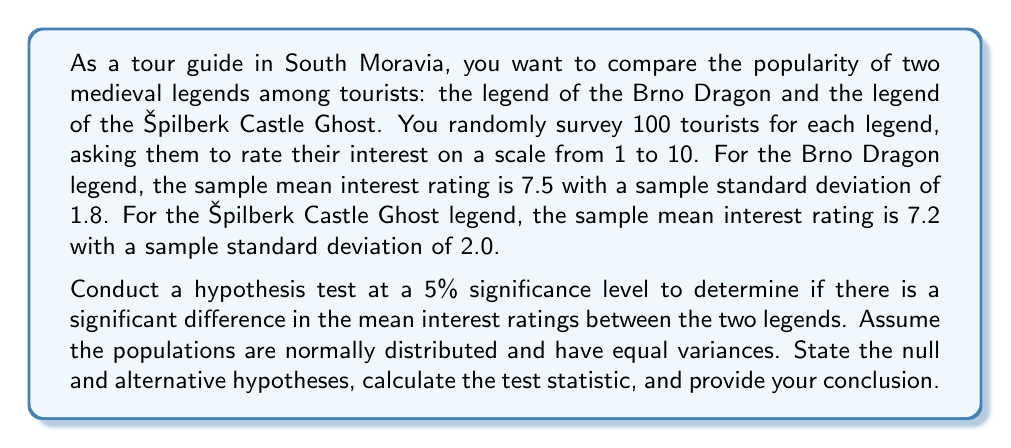Can you answer this question? Let's approach this step-by-step:

1) First, let's state our hypotheses:

   $H_0: \mu_1 = \mu_2$ (The mean interest ratings are equal)
   $H_a: \mu_1 \neq \mu_2$ (The mean interest ratings are different)

   Where $\mu_1$ is the population mean for the Brno Dragon legend and $\mu_2$ is the population mean for the Špilberk Castle Ghost legend.

2) We'll use a two-sample t-test since we're comparing means from two independent samples.

3) Given:
   - Sample size for each group, $n_1 = n_2 = 100$
   - Sample mean for Brno Dragon, $\bar{x}_1 = 7.5$
   - Sample mean for Špilberk Castle Ghost, $\bar{x}_2 = 7.2$
   - Sample standard deviation for Brno Dragon, $s_1 = 1.8$
   - Sample standard deviation for Špilberk Castle Ghost, $s_2 = 2.0$
   - Significance level, $\alpha = 0.05$

4) Calculate the pooled standard deviation:

   $$s_p = \sqrt{\frac{(n_1-1)s_1^2 + (n_2-1)s_2^2}{n_1+n_2-2}}$$
   
   $$s_p = \sqrt{\frac{(100-1)(1.8)^2 + (100-1)(2.0)^2}{100+100-2}} = 1.9052$$

5) Calculate the t-statistic:

   $$t = \frac{\bar{x}_1 - \bar{x}_2}{s_p\sqrt{\frac{2}{n}}} = \frac{7.5 - 7.2}{1.9052\sqrt{\frac{2}{100}}} = 1.1127$$

6) Degrees of freedom: $df = n_1 + n_2 - 2 = 100 + 100 - 2 = 198$

7) For a two-tailed test at $\alpha = 0.05$ with $df = 198$, the critical t-value is approximately $\pm 1.9720$.

8) Since our calculated t-statistic (1.1127) is less than the critical value (1.9720) in absolute terms, we fail to reject the null hypothesis.
Answer: Fail to reject the null hypothesis. There is not enough evidence to conclude that there is a significant difference in the mean interest ratings between the Brno Dragon legend and the Špilberk Castle Ghost legend at the 5% significance level. 